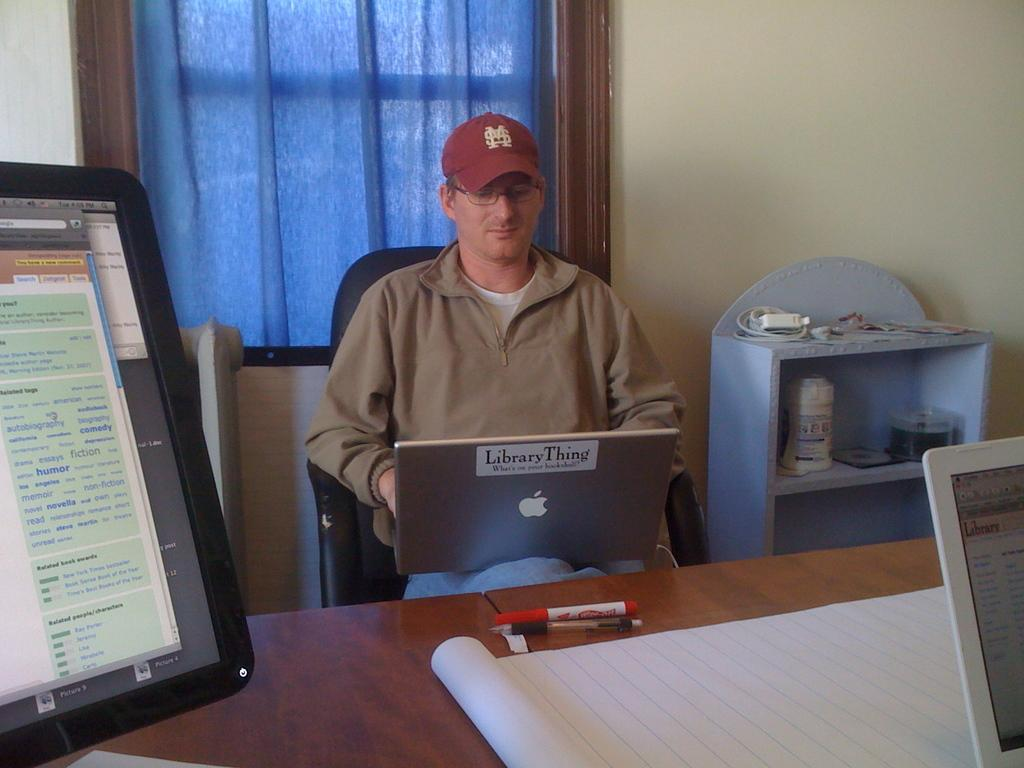<image>
Present a compact description of the photo's key features. A man working on an Apple laptop with a sticker on it that says Library Thing. 